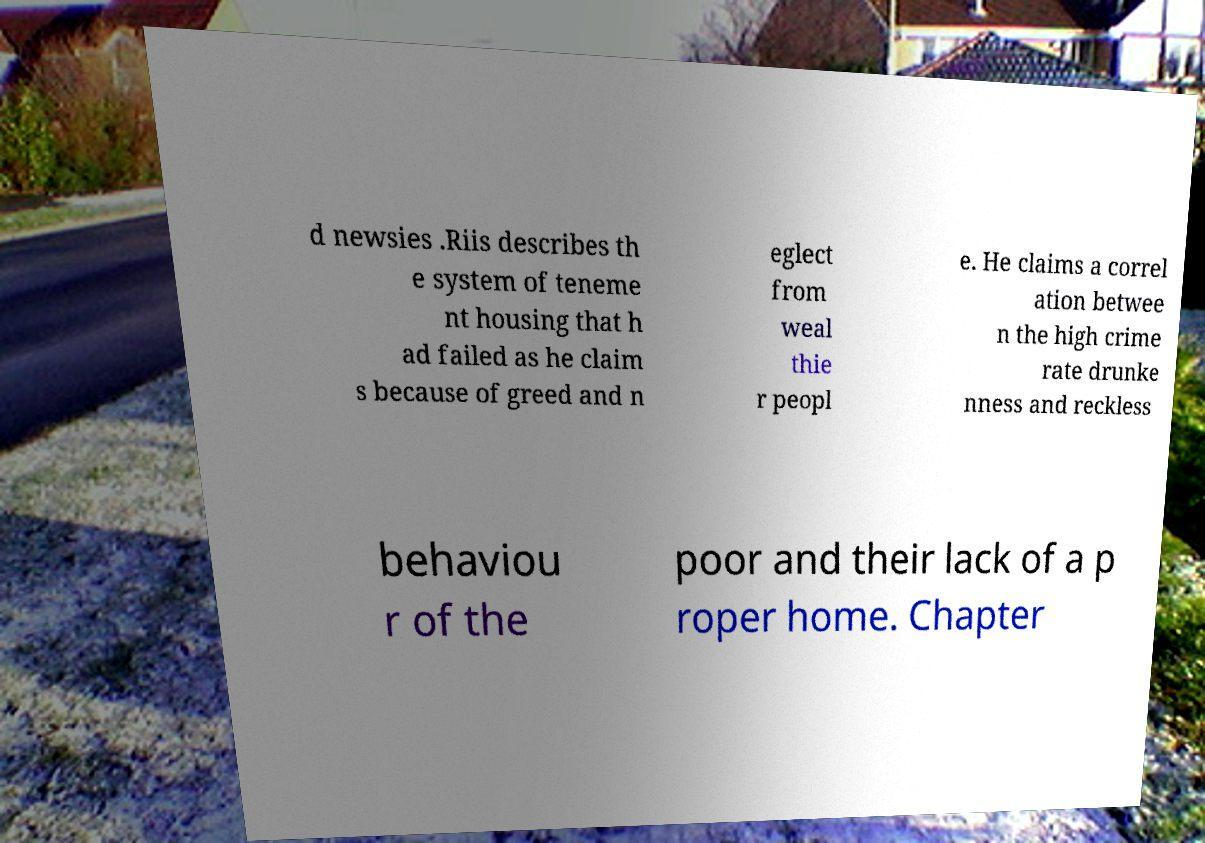Can you accurately transcribe the text from the provided image for me? d newsies .Riis describes th e system of teneme nt housing that h ad failed as he claim s because of greed and n eglect from weal thie r peopl e. He claims a correl ation betwee n the high crime rate drunke nness and reckless behaviou r of the poor and their lack of a p roper home. Chapter 